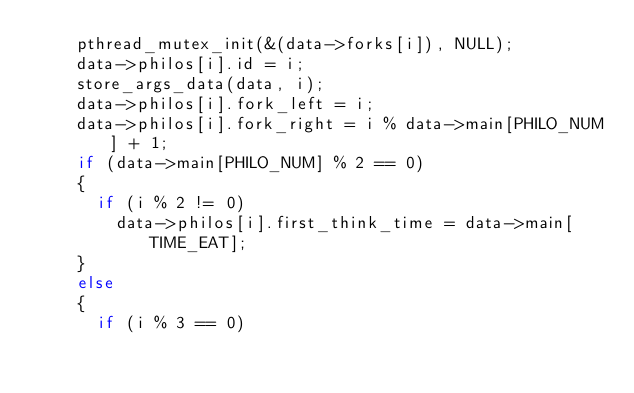Convert code to text. <code><loc_0><loc_0><loc_500><loc_500><_C_>		pthread_mutex_init(&(data->forks[i]), NULL);
		data->philos[i].id = i;
		store_args_data(data, i);
		data->philos[i].fork_left = i;
		data->philos[i].fork_right = i % data->main[PHILO_NUM] + 1;
		if (data->main[PHILO_NUM] % 2 == 0)
		{
			if (i % 2 != 0)
				data->philos[i].first_think_time = data->main[TIME_EAT];
		}
		else
		{
			if (i % 3 == 0)</code> 